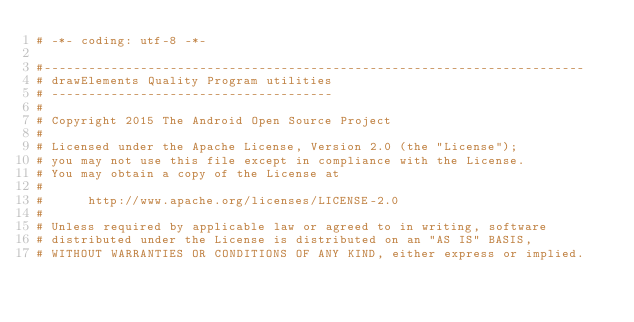Convert code to text. <code><loc_0><loc_0><loc_500><loc_500><_Python_># -*- coding: utf-8 -*-

#-------------------------------------------------------------------------
# drawElements Quality Program utilities
# --------------------------------------
#
# Copyright 2015 The Android Open Source Project
#
# Licensed under the Apache License, Version 2.0 (the "License");
# you may not use this file except in compliance with the License.
# You may obtain a copy of the License at
#
#      http://www.apache.org/licenses/LICENSE-2.0
#
# Unless required by applicable law or agreed to in writing, software
# distributed under the License is distributed on an "AS IS" BASIS,
# WITHOUT WARRANTIES OR CONDITIONS OF ANY KIND, either express or implied.</code> 